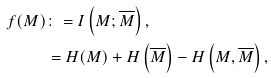<formula> <loc_0><loc_0><loc_500><loc_500>f ( M ) & \colon = I \left ( M ; \overline { M } \right ) , \\ & = H ( M ) + H \left ( \overline { M } \right ) - H \left ( M , \overline { M } \right ) ,</formula> 